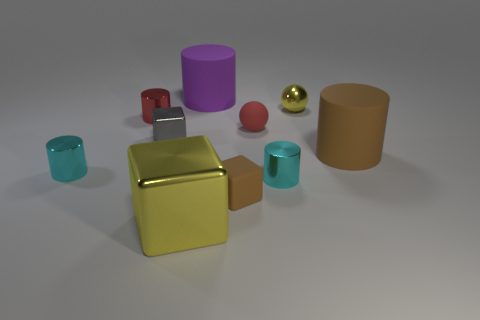Are there any cyan rubber cubes of the same size as the red metallic thing?
Provide a short and direct response. No. What number of rubber objects are large gray balls or red things?
Keep it short and to the point. 1. There is a thing that is the same color as the small metal ball; what shape is it?
Keep it short and to the point. Cube. How many brown matte cubes are there?
Ensure brevity in your answer.  1. Do the yellow thing in front of the gray object and the yellow object to the right of the small brown matte object have the same material?
Keep it short and to the point. Yes. There is a red ball that is the same material as the purple thing; what is its size?
Keep it short and to the point. Small. There is a brown object that is on the right side of the rubber sphere; what shape is it?
Your response must be concise. Cylinder. There is a big rubber cylinder left of the small brown block; is it the same color as the tiny cube right of the yellow shiny cube?
Your response must be concise. No. There is a metallic block that is the same color as the metallic ball; what is its size?
Your response must be concise. Large. Are there any brown rubber spheres?
Give a very brief answer. No. 